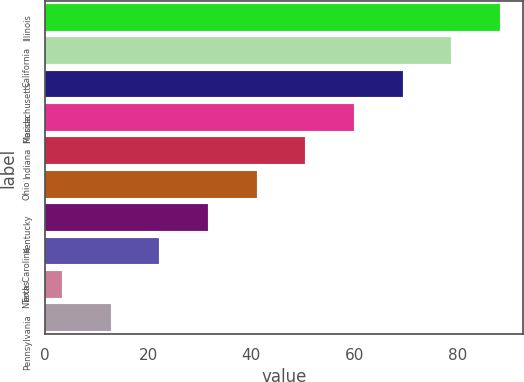<chart> <loc_0><loc_0><loc_500><loc_500><bar_chart><fcel>Illinois<fcel>California<fcel>Massachusetts<fcel>Florida<fcel>Indiana<fcel>Ohio<fcel>Kentucky<fcel>North Carolina<fcel>Texas<fcel>Pennsylvania<nl><fcel>88.26<fcel>78.82<fcel>69.38<fcel>59.94<fcel>50.5<fcel>41.06<fcel>31.62<fcel>22.18<fcel>3.3<fcel>12.74<nl></chart> 